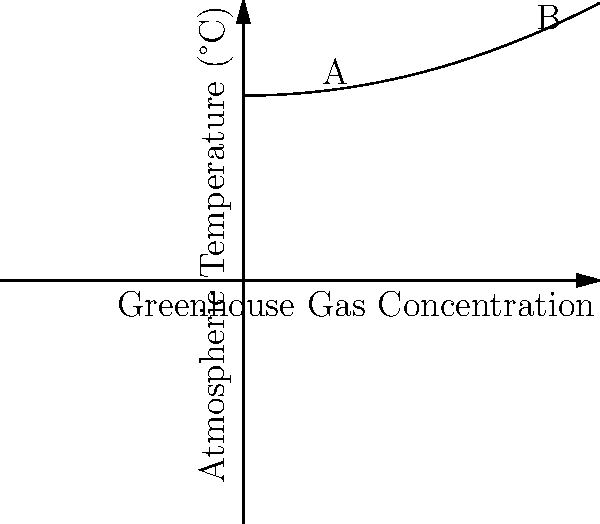As an urban farmer considering the environmental impact of your greenhouse, you're studying the relationship between greenhouse gas concentrations and atmospheric temperature. The graph shows this relationship. If the greenhouse gas concentration increases from point A to point B, by approximately how many degrees Celsius does the atmospheric temperature rise? To solve this problem, we need to follow these steps:

1. Identify the points A and B on the graph:
   Point A is at a lower greenhouse gas concentration
   Point B is at a higher greenhouse gas concentration

2. Estimate the temperature at point A:
   The y-coordinate of point A is approximately 12°C

3. Estimate the temperature at point B:
   The y-coordinate of point B is approximately 23°C

4. Calculate the difference in temperature:
   Temperature difference = Temperature at B - Temperature at A
   $23°C - 12°C = 11°C$

5. Round to the nearest whole number:
   11°C rounds to 11°C

Therefore, the atmospheric temperature rises by approximately 11°C when the greenhouse gas concentration increases from point A to point B.
Answer: 11°C 